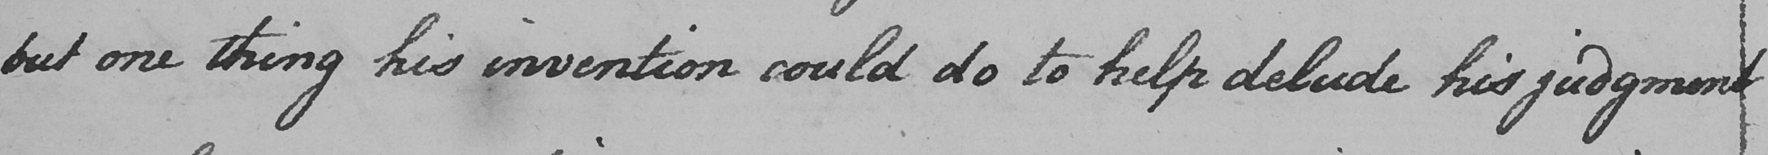What does this handwritten line say? but one thing his invention could do to help delude his judgment 